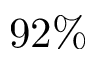Convert formula to latex. <formula><loc_0><loc_0><loc_500><loc_500>9 2 \%</formula> 